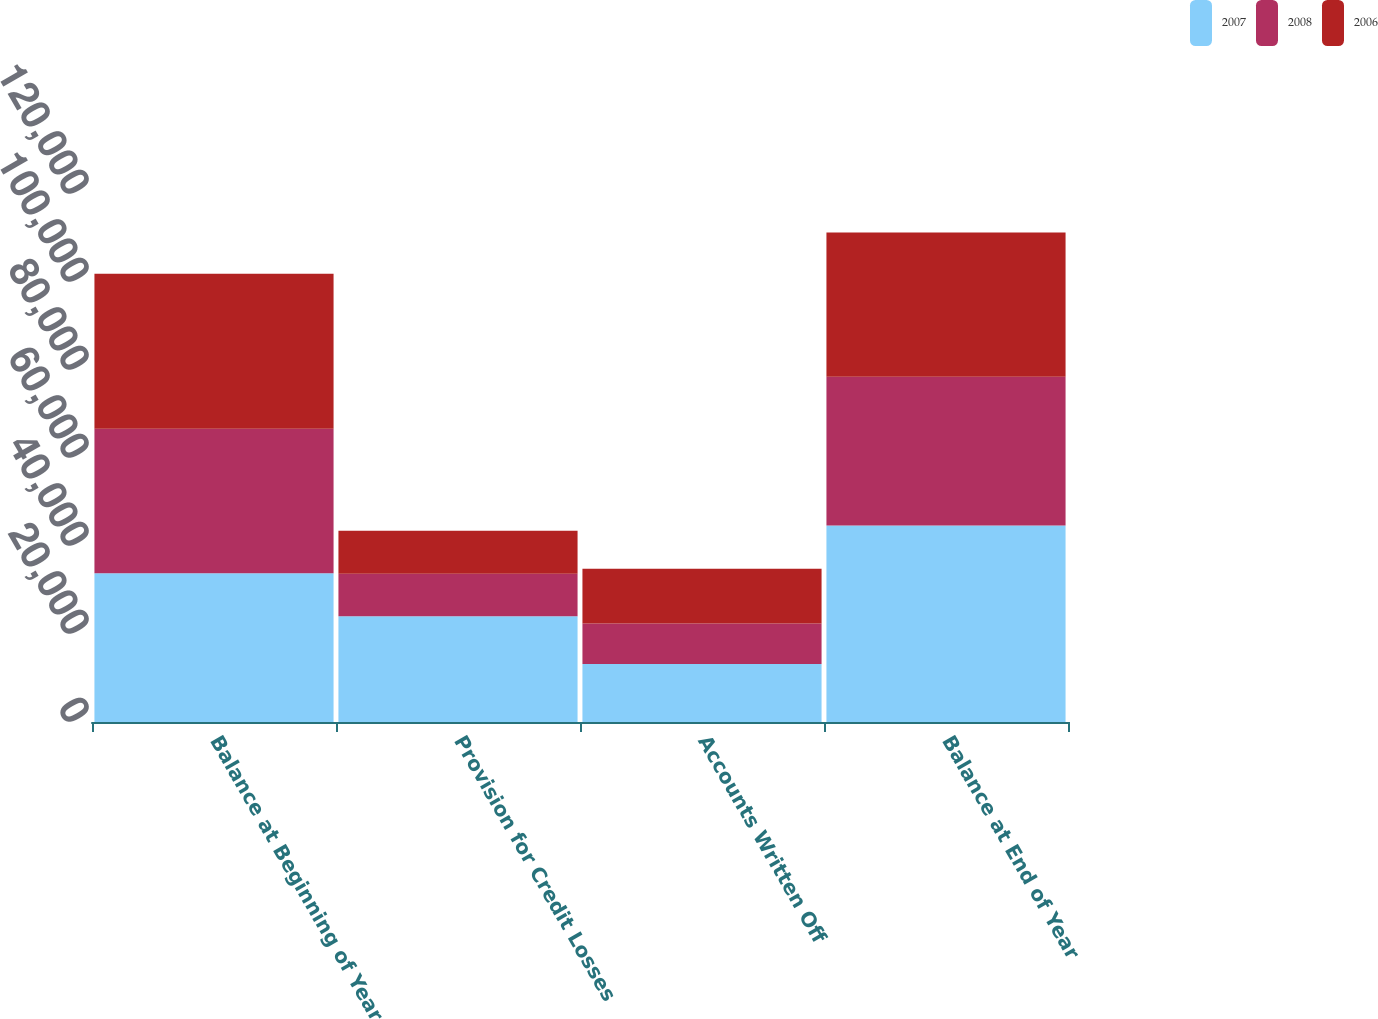Convert chart to OTSL. <chart><loc_0><loc_0><loc_500><loc_500><stacked_bar_chart><ecel><fcel>Balance at Beginning of Year<fcel>Provision for Credit Losses<fcel>Accounts Written Off<fcel>Balance at End of Year<nl><fcel>2007<fcel>33810<fcel>24037<fcel>13197<fcel>44650<nl><fcel>2008<fcel>32817<fcel>9672<fcel>9174<fcel>33810<nl><fcel>2006<fcel>35239<fcel>9730<fcel>12473<fcel>32817<nl></chart> 